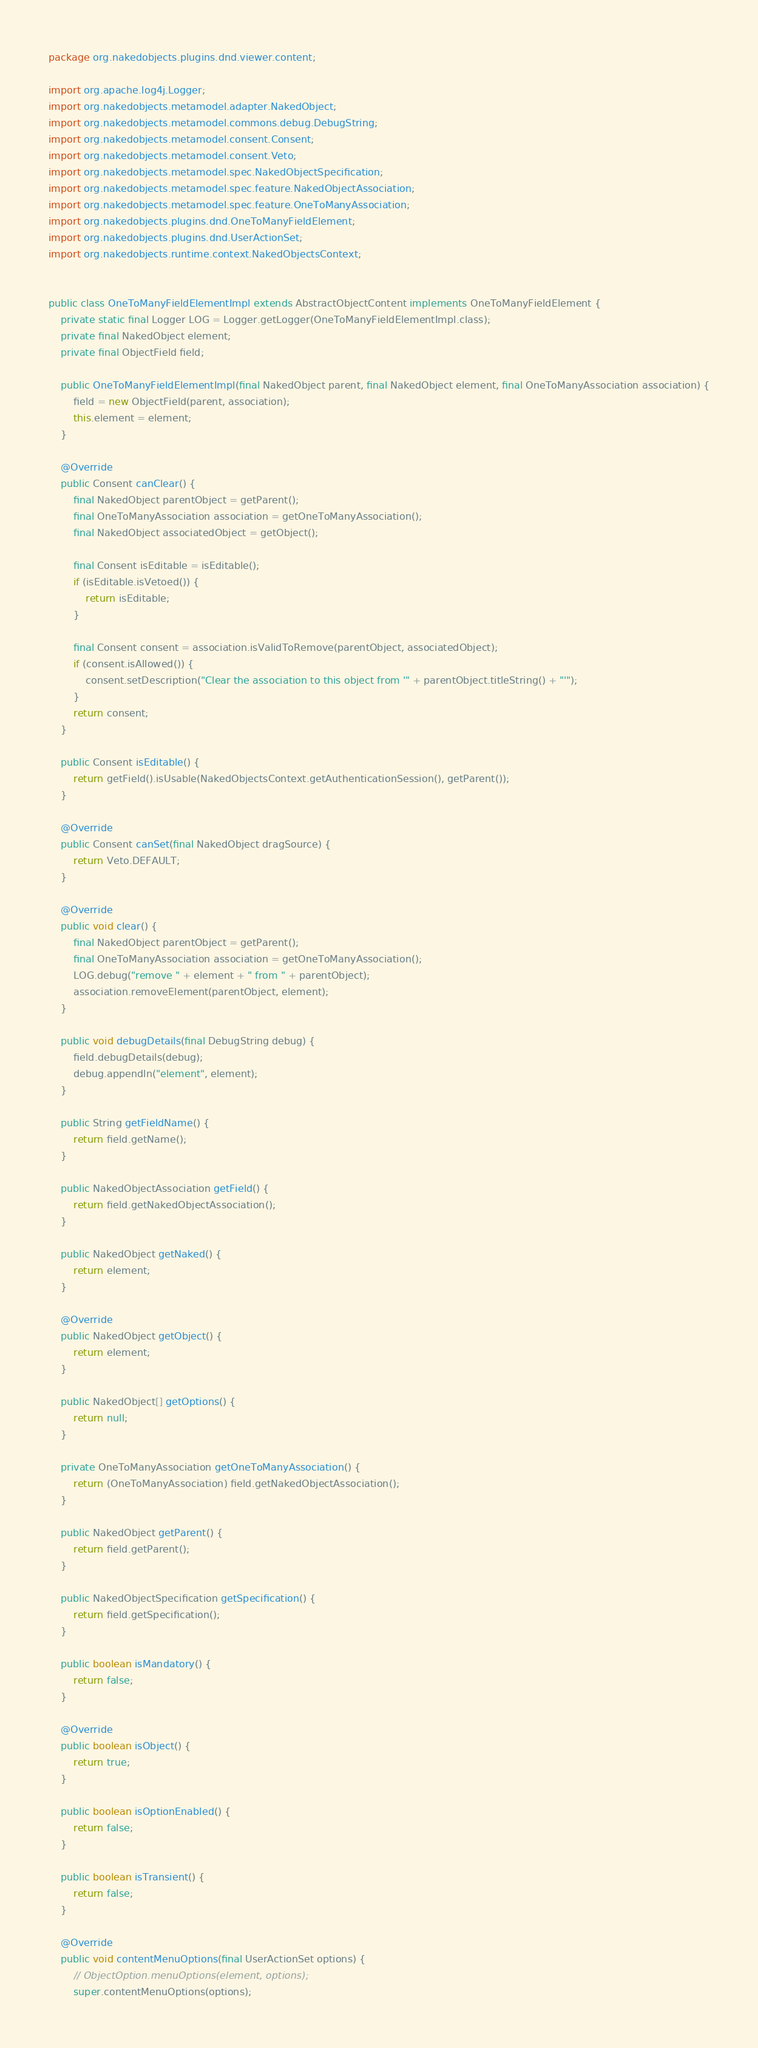Convert code to text. <code><loc_0><loc_0><loc_500><loc_500><_Java_>package org.nakedobjects.plugins.dnd.viewer.content;

import org.apache.log4j.Logger;
import org.nakedobjects.metamodel.adapter.NakedObject;
import org.nakedobjects.metamodel.commons.debug.DebugString;
import org.nakedobjects.metamodel.consent.Consent;
import org.nakedobjects.metamodel.consent.Veto;
import org.nakedobjects.metamodel.spec.NakedObjectSpecification;
import org.nakedobjects.metamodel.spec.feature.NakedObjectAssociation;
import org.nakedobjects.metamodel.spec.feature.OneToManyAssociation;
import org.nakedobjects.plugins.dnd.OneToManyFieldElement;
import org.nakedobjects.plugins.dnd.UserActionSet;
import org.nakedobjects.runtime.context.NakedObjectsContext;


public class OneToManyFieldElementImpl extends AbstractObjectContent implements OneToManyFieldElement {
    private static final Logger LOG = Logger.getLogger(OneToManyFieldElementImpl.class);
    private final NakedObject element;
    private final ObjectField field;

    public OneToManyFieldElementImpl(final NakedObject parent, final NakedObject element, final OneToManyAssociation association) {
        field = new ObjectField(parent, association);
        this.element = element;
    }

    @Override
    public Consent canClear() {
        final NakedObject parentObject = getParent();
        final OneToManyAssociation association = getOneToManyAssociation();
        final NakedObject associatedObject = getObject();

        final Consent isEditable = isEditable();
        if (isEditable.isVetoed()) {
            return isEditable;
        }

        final Consent consent = association.isValidToRemove(parentObject, associatedObject);
        if (consent.isAllowed()) {
            consent.setDescription("Clear the association to this object from '" + parentObject.titleString() + "'");
        }
        return consent;
    }

    public Consent isEditable() {
        return getField().isUsable(NakedObjectsContext.getAuthenticationSession(), getParent());
    }

    @Override
    public Consent canSet(final NakedObject dragSource) {
        return Veto.DEFAULT;
    }

    @Override
    public void clear() {
        final NakedObject parentObject = getParent();
        final OneToManyAssociation association = getOneToManyAssociation();
        LOG.debug("remove " + element + " from " + parentObject);
        association.removeElement(parentObject, element);
    }

    public void debugDetails(final DebugString debug) {
        field.debugDetails(debug);
        debug.appendln("element", element);
    }

    public String getFieldName() {
        return field.getName();
    }

    public NakedObjectAssociation getField() {
        return field.getNakedObjectAssociation();
    }

    public NakedObject getNaked() {
        return element;
    }

    @Override
    public NakedObject getObject() {
        return element;
    }

    public NakedObject[] getOptions() {
        return null;
    }

    private OneToManyAssociation getOneToManyAssociation() {
        return (OneToManyAssociation) field.getNakedObjectAssociation();
    }

    public NakedObject getParent() {
        return field.getParent();
    }

    public NakedObjectSpecification getSpecification() {
        return field.getSpecification();
    }

    public boolean isMandatory() {
        return false;
    }

    @Override
    public boolean isObject() {
        return true;
    }

    public boolean isOptionEnabled() {
        return false;
    }

    public boolean isTransient() {
        return false;
    }

    @Override
    public void contentMenuOptions(final UserActionSet options) {
        // ObjectOption.menuOptions(element, options);
        super.contentMenuOptions(options);</code> 